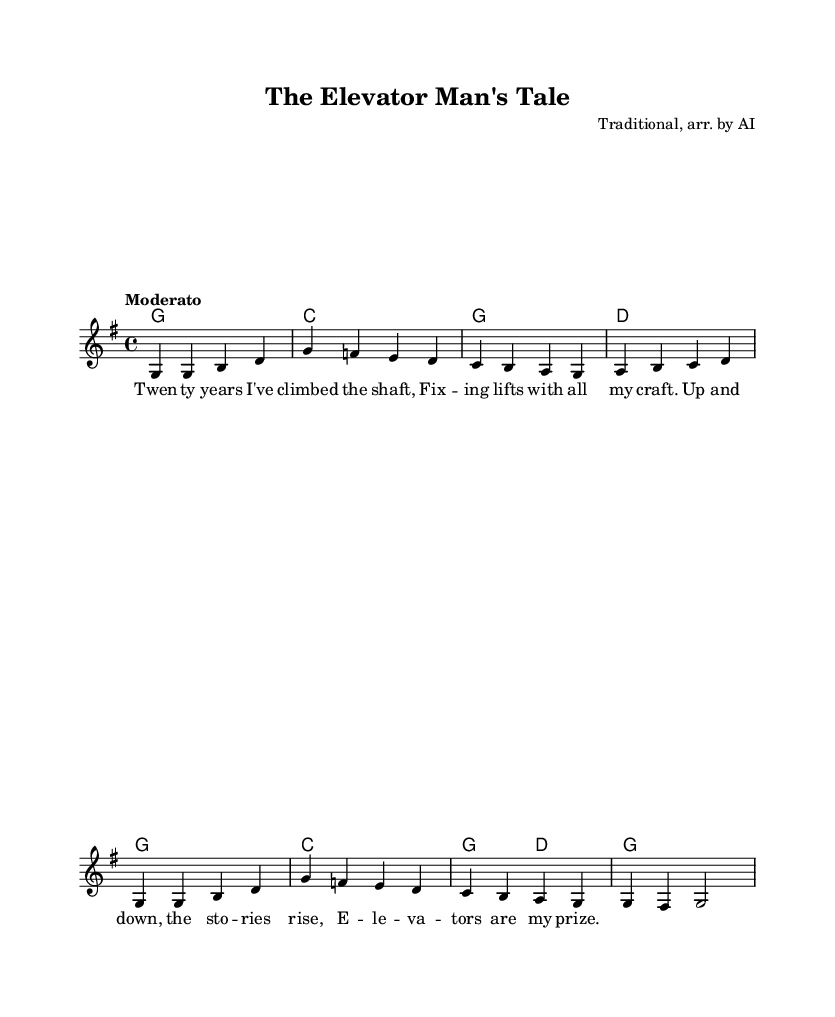What is the key signature of this music? The key signature indicated at the beginning of the piece shows one sharp, which corresponds to G major.
Answer: G major What is the time signature of the music? The time signature shown at the beginning of the piece is 4 over 4, indicating four beats per measure.
Answer: 4/4 What is the tempo marking for this piece? The tempo marking is "Moderato," which suggests a moderate pace for the performance.
Answer: Moderato How many measures are there in the melody? By counting the vertical bar lines in the melody section, there are a total of eight measures.
Answer: Eight How many lyrics lines are associated with the melody line? The lyrics are written in a single line corresponding to the melody, indicating one complete lyric line.
Answer: One What is the title of this music piece? The title can be found in the header section at the top of the sheet music, which is "The Elevator Man's Tale."
Answer: The Elevator Man's Tale Which musical form does this song primarily follow? The song follows a verse format in its structure, with lyrics telling a story and matching the melody.
Answer: Verse 